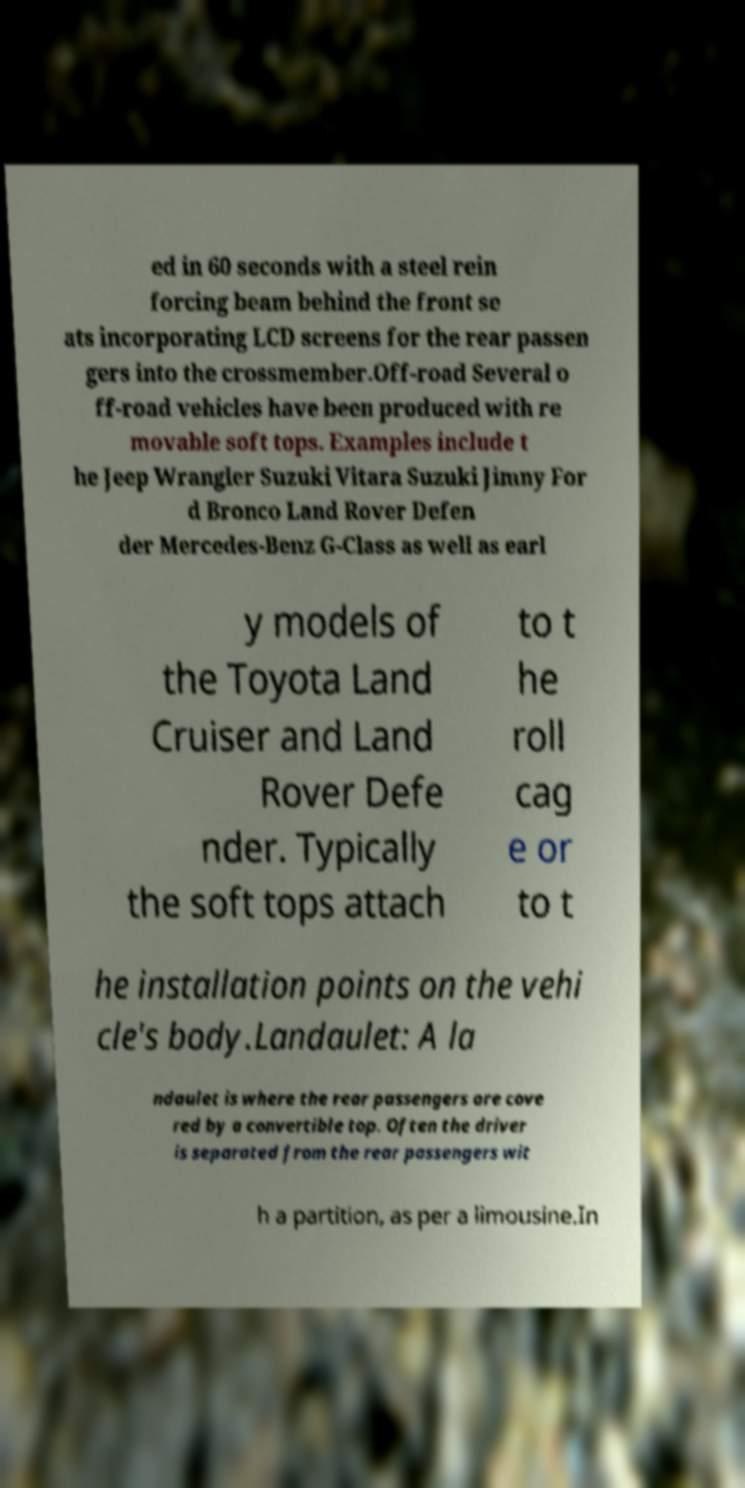Please read and relay the text visible in this image. What does it say? ed in 60 seconds with a steel rein forcing beam behind the front se ats incorporating LCD screens for the rear passen gers into the crossmember.Off-road Several o ff-road vehicles have been produced with re movable soft tops. Examples include t he Jeep Wrangler Suzuki Vitara Suzuki Jimny For d Bronco Land Rover Defen der Mercedes-Benz G-Class as well as earl y models of the Toyota Land Cruiser and Land Rover Defe nder. Typically the soft tops attach to t he roll cag e or to t he installation points on the vehi cle's body.Landaulet: A la ndaulet is where the rear passengers are cove red by a convertible top. Often the driver is separated from the rear passengers wit h a partition, as per a limousine.In 